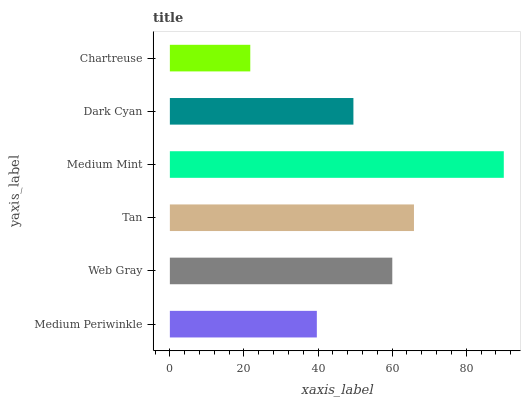Is Chartreuse the minimum?
Answer yes or no. Yes. Is Medium Mint the maximum?
Answer yes or no. Yes. Is Web Gray the minimum?
Answer yes or no. No. Is Web Gray the maximum?
Answer yes or no. No. Is Web Gray greater than Medium Periwinkle?
Answer yes or no. Yes. Is Medium Periwinkle less than Web Gray?
Answer yes or no. Yes. Is Medium Periwinkle greater than Web Gray?
Answer yes or no. No. Is Web Gray less than Medium Periwinkle?
Answer yes or no. No. Is Web Gray the high median?
Answer yes or no. Yes. Is Dark Cyan the low median?
Answer yes or no. Yes. Is Medium Periwinkle the high median?
Answer yes or no. No. Is Tan the low median?
Answer yes or no. No. 